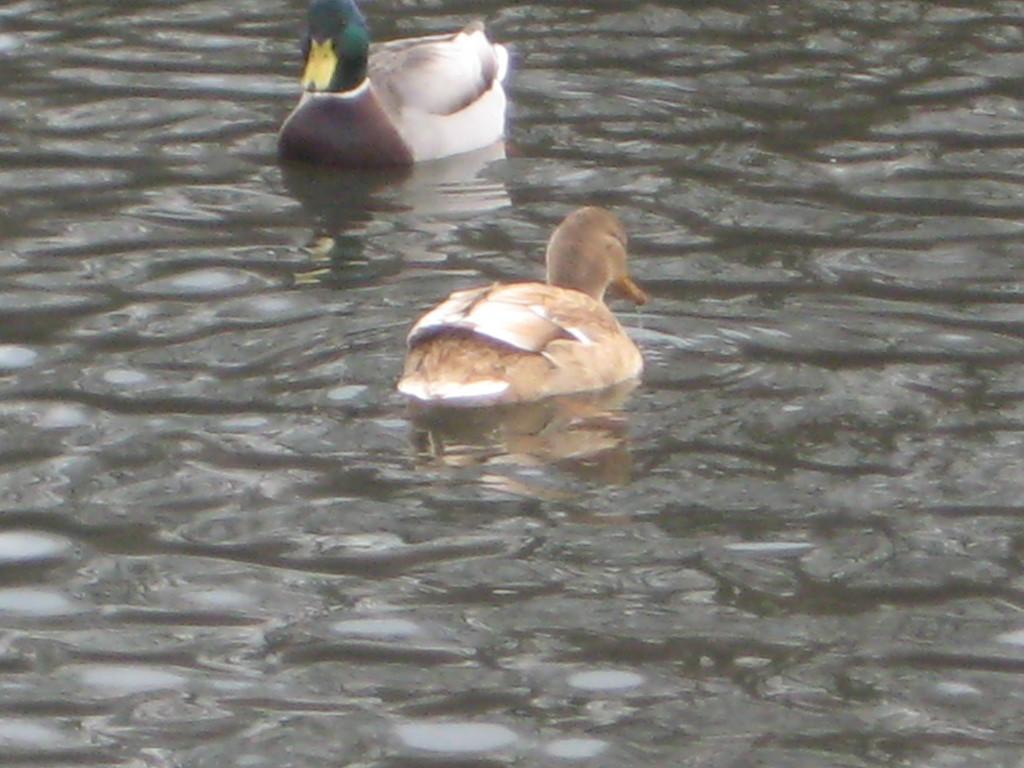How would you summarize this image in a sentence or two? In this picture I can see two ducks in the water. 